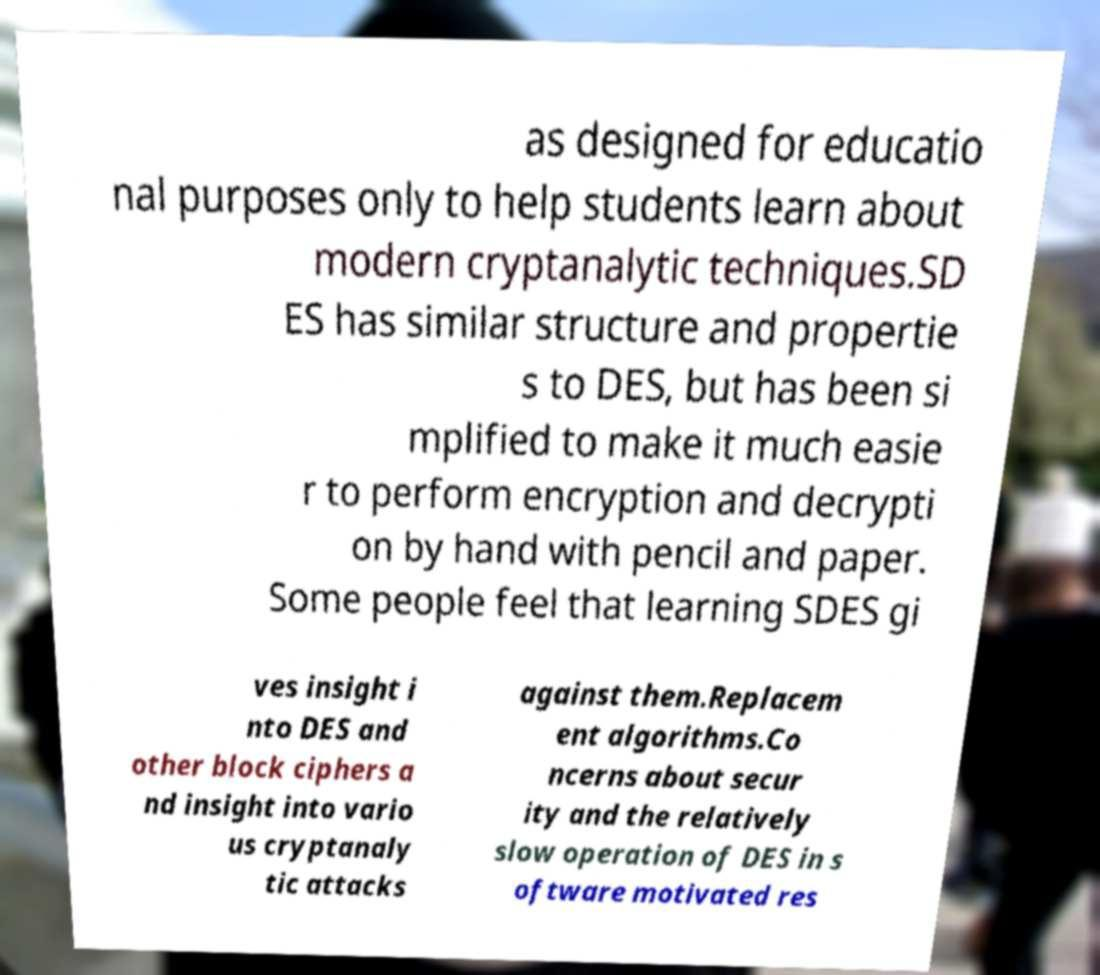There's text embedded in this image that I need extracted. Can you transcribe it verbatim? as designed for educatio nal purposes only to help students learn about modern cryptanalytic techniques.SD ES has similar structure and propertie s to DES, but has been si mplified to make it much easie r to perform encryption and decrypti on by hand with pencil and paper. Some people feel that learning SDES gi ves insight i nto DES and other block ciphers a nd insight into vario us cryptanaly tic attacks against them.Replacem ent algorithms.Co ncerns about secur ity and the relatively slow operation of DES in s oftware motivated res 